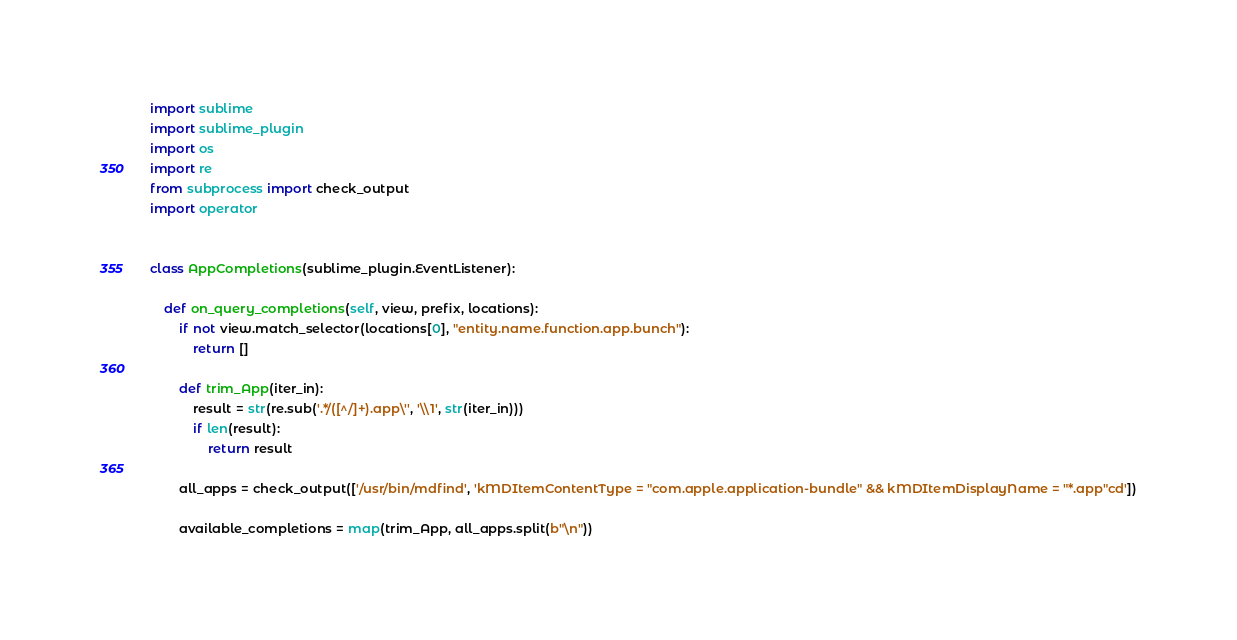Convert code to text. <code><loc_0><loc_0><loc_500><loc_500><_Python_>import sublime
import sublime_plugin
import os
import re
from subprocess import check_output
import operator


class AppCompletions(sublime_plugin.EventListener):

    def on_query_completions(self, view, prefix, locations):
        if not view.match_selector(locations[0], "entity.name.function.app.bunch"):
            return []

        def trim_App(iter_in):
            result = str(re.sub('.*/([^/]+).app\'', '\\1', str(iter_in)))
            if len(result):
                return result

        all_apps = check_output(['/usr/bin/mdfind', 'kMDItemContentType = "com.apple.application-bundle" && kMDItemDisplayName = "*.app"cd'])

        available_completions = map(trim_App, all_apps.split(b"\n"))
</code> 